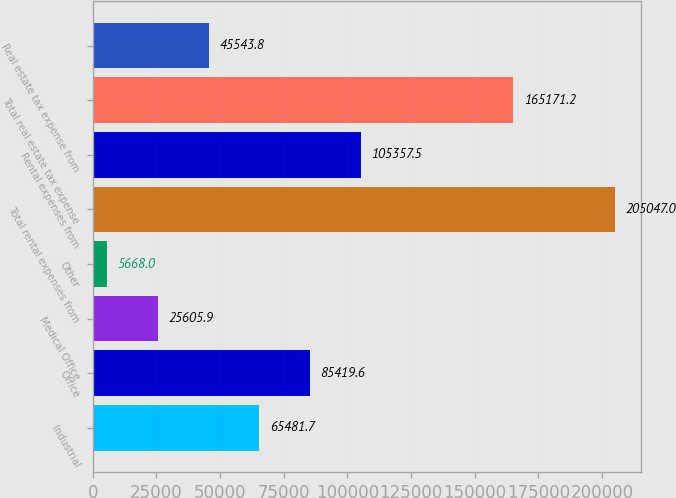Convert chart to OTSL. <chart><loc_0><loc_0><loc_500><loc_500><bar_chart><fcel>Industrial<fcel>Office<fcel>Medical Office<fcel>Other<fcel>Total rental expenses from<fcel>Rental expenses from<fcel>Total real estate tax expense<fcel>Real estate tax expense from<nl><fcel>65481.7<fcel>85419.6<fcel>25605.9<fcel>5668<fcel>205047<fcel>105358<fcel>165171<fcel>45543.8<nl></chart> 